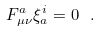Convert formula to latex. <formula><loc_0><loc_0><loc_500><loc_500>F _ { \mu \nu } ^ { a } \xi _ { a } ^ { i } = 0 \ .</formula> 